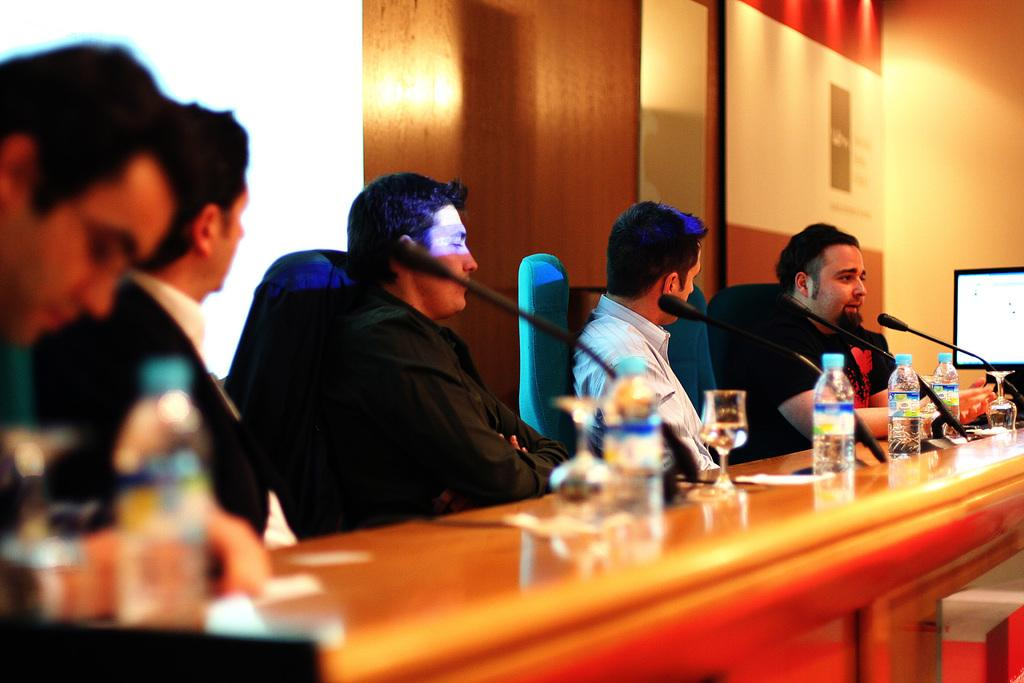What is happening in the image involving a group of men? In the image, there is a group of men at a meeting. What is the role of the man who is speaking? The man who is speaking is likely presenting or sharing information during the meeting. What are the other men doing during the meeting? The other men are listening to the speaker. How many snakes are present in the image? There are no snakes present in the image; it features a group of men at a meeting. Can you describe the color of the fly that is buzzing around the speaker? There is no fly present in the image; it features a group of men at a meeting. 